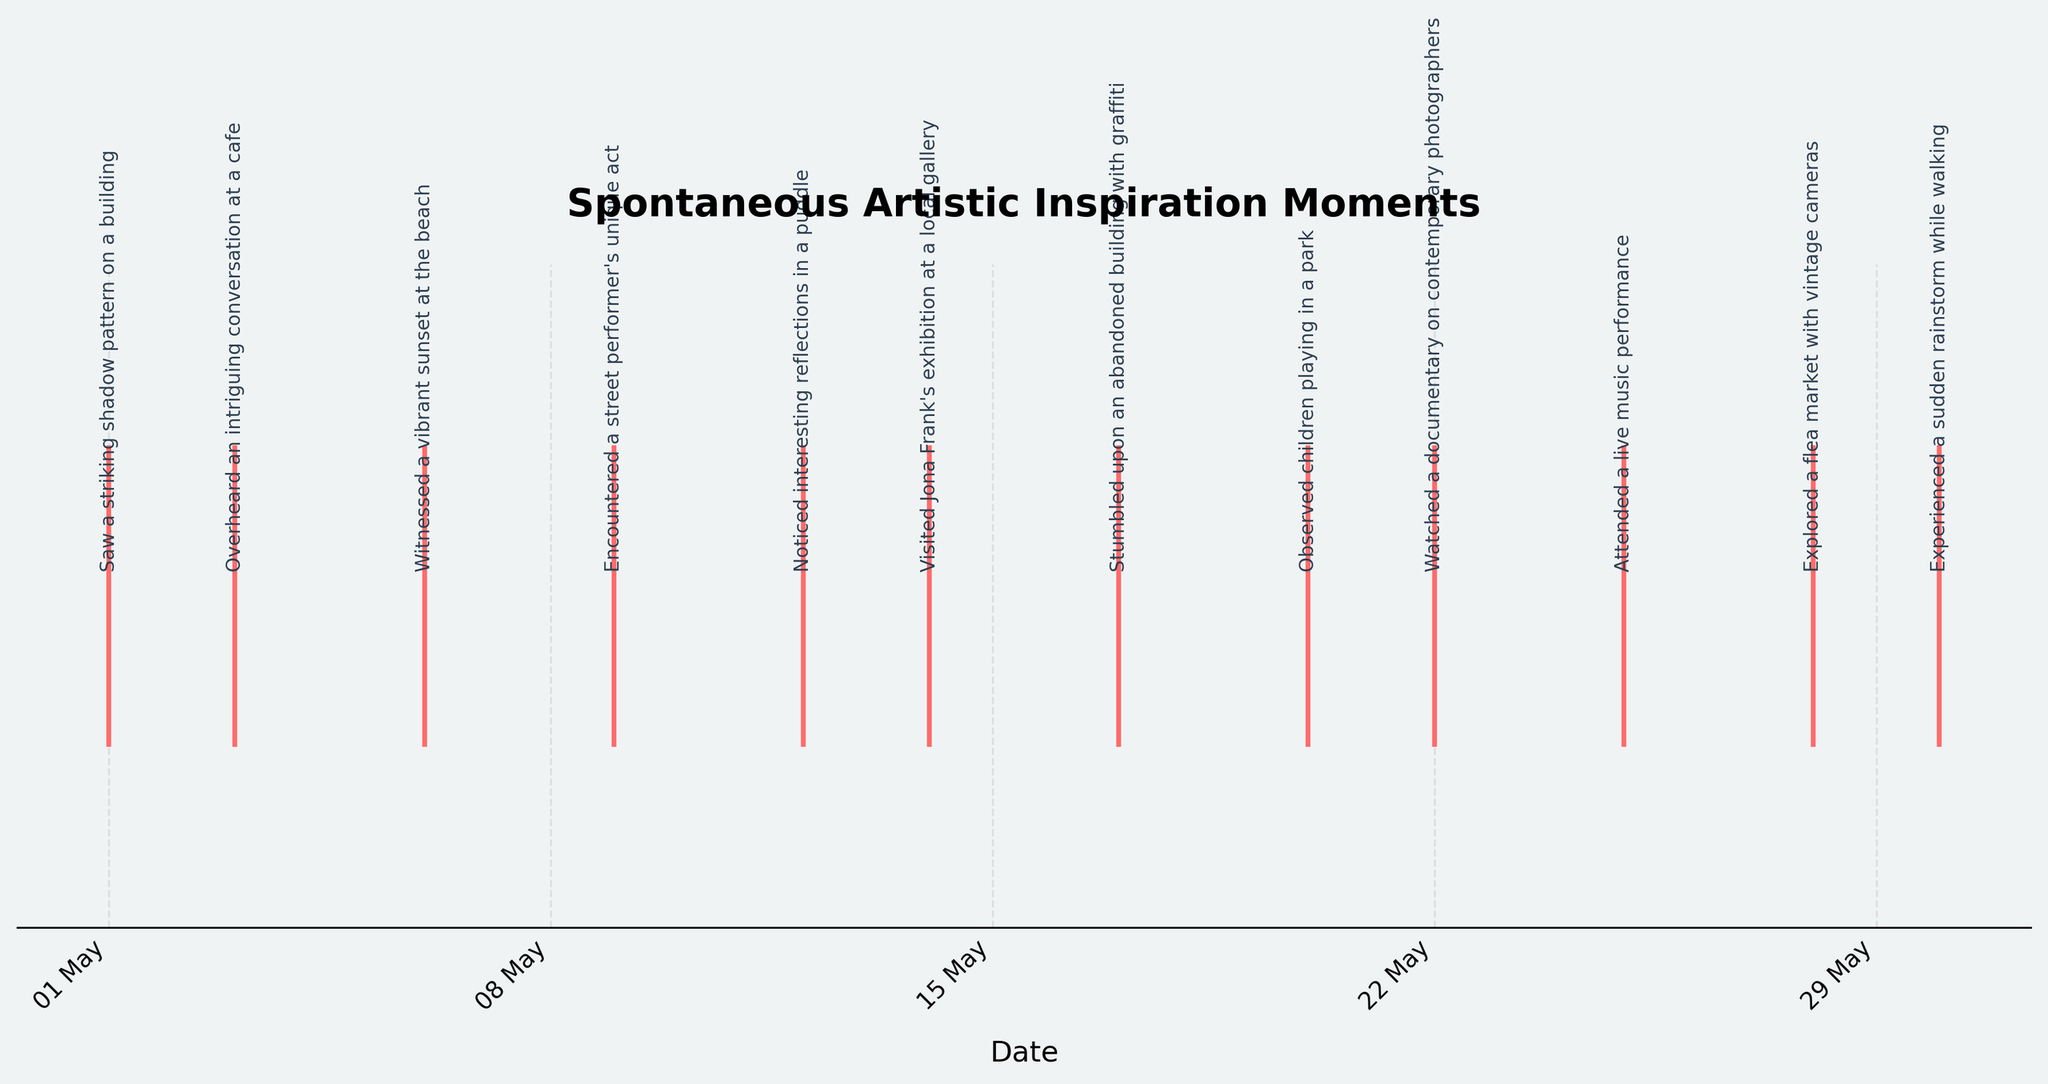What is the title of the plot? The title of the plot is positioned at the top-center of the figure. It is written in bold, indicating the main theme or subject of the plot.
Answer: Spontaneous Artistic Inspiration Moments How many artistic inspiration moments occurred over the month? Count the number of event annotations present along the x-axis of the plot. Each annotation represents an artistic inspiration moment.
Answer: 12 On which date did the artist visit Jona Frank's exhibition? Find the annotation with "Visited Jona Frank's exhibition at a local gallery". Then look directly below it to see the corresponding date on the x-axis.
Answer: 14 May What is the average interval in days between each inspiration moment? There are 12 moments spanning from May 1 to May 30. The interval is (30 - 1) / (12 - 1).
Answer: 2.64 days Which week (starting Monday) had the most inspiration moments? Observe the placement of annotations and their dates. Identify which week (Monday to Sunday) has the highest concentration of moments.
Answer: May 1-7 How many inspiration moments occurred in the second half of the month? Focus on the annotations dated from May 16 to May 30 and count them.
Answer: 6 Did more artistic inspirations occur in the first or the second week of May? Compare the count of annotations from May 1-7 (first week) with those from May 8-14 (second week).
Answer: First week (3 vs 2) Which inspiration moment took place after observing children playing in a park? Locate the event labeled "Observed children playing in a park". Find the next event by observing the events to the right on the x-axis.
Answer: Watched a documentary on contemporary photographers Between which two consecutive dates did the shortest gap between inspiration moments occur? Compare the dates of consecutive moments and identify the pair with the smallest interval.
Answer: May 28 and May 30 How many inspiration moments occurred before the artist attended the live music performance? Locate the "Attended a live music performance" annotation. Count the number of annotations to the left of it on the x-axis.
Answer: 8 